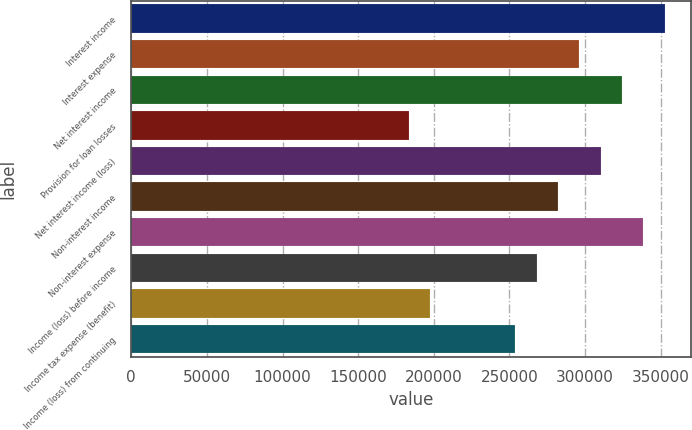Convert chart. <chart><loc_0><loc_0><loc_500><loc_500><bar_chart><fcel>Interest income<fcel>Interest expense<fcel>Net interest income<fcel>Provision for loan losses<fcel>Net interest income (loss)<fcel>Non-interest income<fcel>Non-interest expense<fcel>Income (loss) before income<fcel>Income tax expense (benefit)<fcel>Income (loss) from continuing<nl><fcel>352604<fcel>296187<fcel>324395<fcel>183354<fcel>310291<fcel>282083<fcel>338500<fcel>267979<fcel>197458<fcel>253875<nl></chart> 